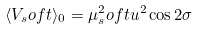<formula> <loc_0><loc_0><loc_500><loc_500>\langle V _ { s } o f t \rangle _ { 0 } = \mu ^ { 2 } _ { s } o f t u ^ { 2 } \cos { 2 \sigma }</formula> 